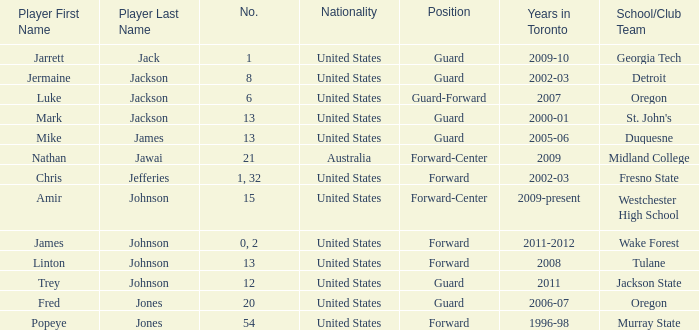What are the nationality of the players on the Fresno State school/club team? United States. Could you parse the entire table as a dict? {'header': ['Player First Name', 'Player Last Name', 'No.', 'Nationality', 'Position', 'Years in Toronto', 'School/Club Team'], 'rows': [['Jarrett', 'Jack', '1', 'United States', 'Guard', '2009-10', 'Georgia Tech'], ['Jermaine', 'Jackson', '8', 'United States', 'Guard', '2002-03', 'Detroit'], ['Luke', 'Jackson', '6', 'United States', 'Guard-Forward', '2007', 'Oregon'], ['Mark', 'Jackson', '13', 'United States', 'Guard', '2000-01', "St. John's"], ['Mike', 'James', '13', 'United States', 'Guard', '2005-06', 'Duquesne'], ['Nathan', 'Jawai', '21', 'Australia', 'Forward-Center', '2009', 'Midland College'], ['Chris', 'Jefferies', '1, 32', 'United States', 'Forward', '2002-03', 'Fresno State'], ['Amir', 'Johnson', '15', 'United States', 'Forward-Center', '2009-present', 'Westchester High School'], ['James', 'Johnson', '0, 2', 'United States', 'Forward', '2011-2012', 'Wake Forest'], ['Linton', 'Johnson', '13', 'United States', 'Forward', '2008', 'Tulane'], ['Trey', 'Johnson', '12', 'United States', 'Guard', '2011', 'Jackson State'], ['Fred', 'Jones', '20', 'United States', 'Guard', '2006-07', 'Oregon'], ['Popeye', 'Jones', '54', 'United States', 'Forward', '1996-98', 'Murray State']]} 